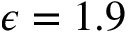Convert formula to latex. <formula><loc_0><loc_0><loc_500><loc_500>\epsilon = 1 . 9</formula> 